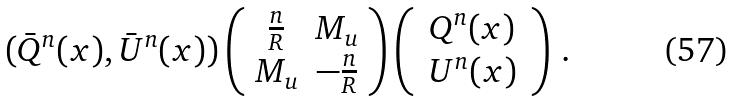Convert formula to latex. <formula><loc_0><loc_0><loc_500><loc_500>( \bar { Q } ^ { n } ( x ) , \bar { U } ^ { n } ( x ) ) \left ( \begin{array} { c r } \frac { n } { R } & M _ { u } \\ M _ { u } & - \frac { n } { R } \end{array} \right ) \left ( \, \begin{array} { c } Q ^ { n } ( x ) \\ U ^ { n } ( x ) \end{array} \, \right ) \, .</formula> 